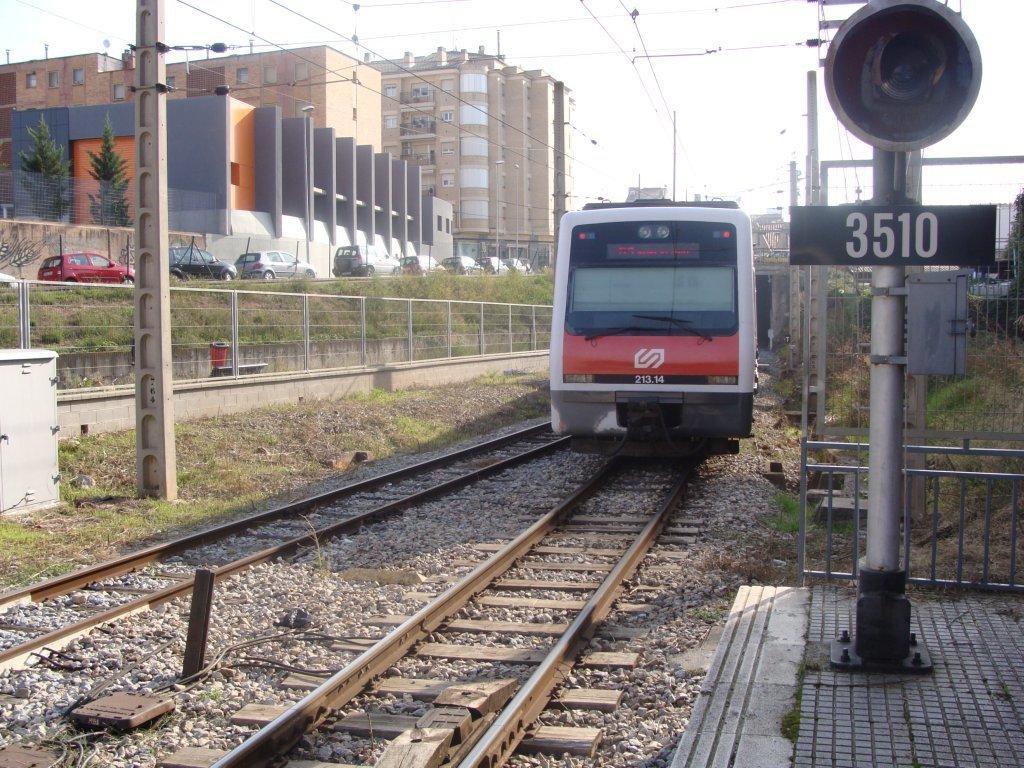Please provide a concise description of this image. In this picture I can see few buildings, trees and few cars and I can see poles and a train moving on the railway track and I can see another track on the side and I can see a cloudy sky and a metal fence on the left side. 